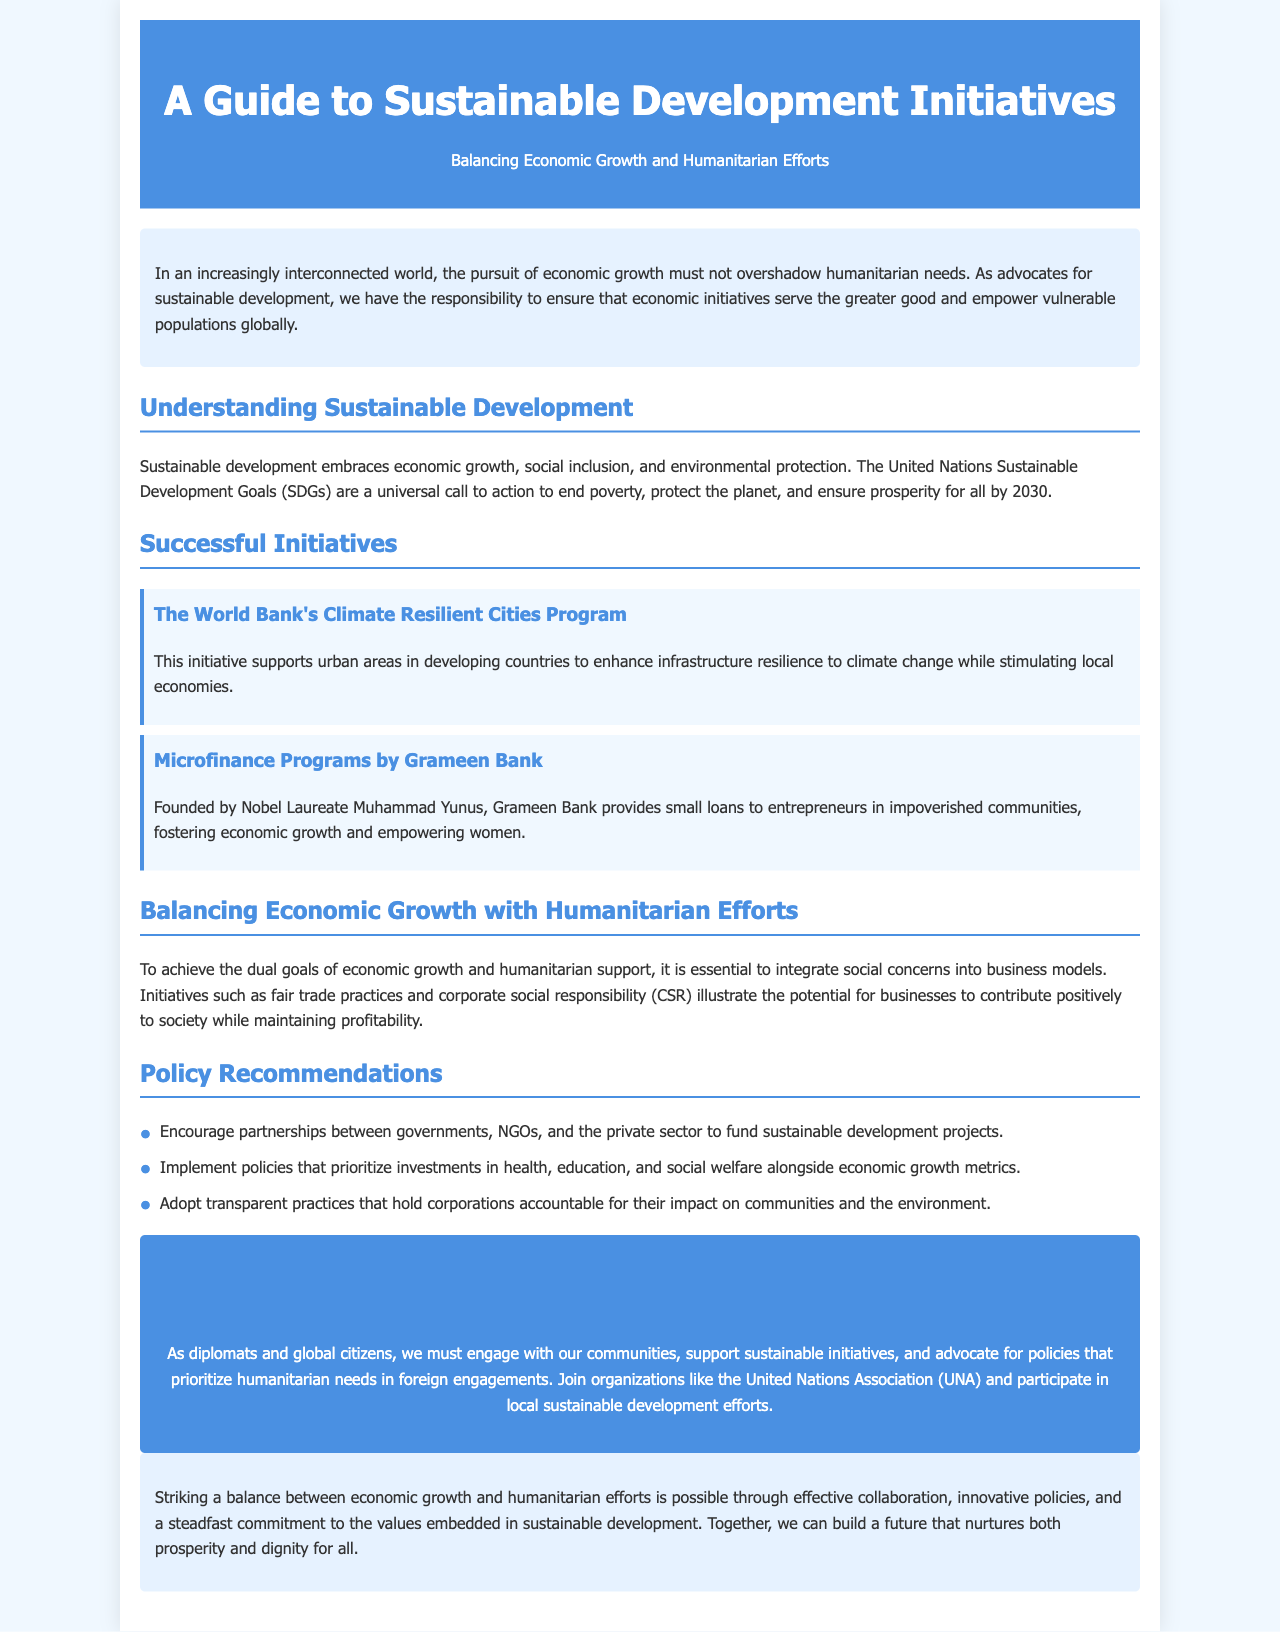What are the United Nations Sustainable Development Goals a call to action for? The United Nations Sustainable Development Goals are a universal call to action to end poverty, protect the planet, and ensure prosperity for all by 2030.
Answer: End poverty, protect the planet, ensure prosperity for all Who founded Grameen Bank? Grameen Bank was founded by Nobel Laureate Muhammad Yunus.
Answer: Muhammad Yunus What does the Climate Resilient Cities Program support? The Climate Resilient Cities Program supports urban areas in developing countries to enhance infrastructure resilience to climate change while stimulating local economies.
Answer: Enhancing resilience to climate change What are two types of initiatives that illustrate balancing economic growth and humanitarian efforts? Fair trade practices and corporate social responsibility (CSR) illustrate the potential for businesses to contribute positively to society while maintaining profitability.
Answer: Fair trade practices, CSR What is one policy recommendation mentioned in the brochure? The brochure recommends implementing policies that prioritize investments in health, education, and social welfare alongside economic growth metrics.
Answer: Prioritize investments in health and education What is the primary theme of the brochure? The primary theme of the brochure is balancing economic growth and humanitarian efforts in sustainable development initiatives.
Answer: Balancing economic growth and humanitarian efforts What organization can individuals join to support sustainable initiatives? Individuals can join organizations like the United Nations Association (UNA) to support sustainable initiatives.
Answer: United Nations Association (UNA) What type of document is this? This document is a brochure providing a guide to sustainable development initiatives.
Answer: Brochure 